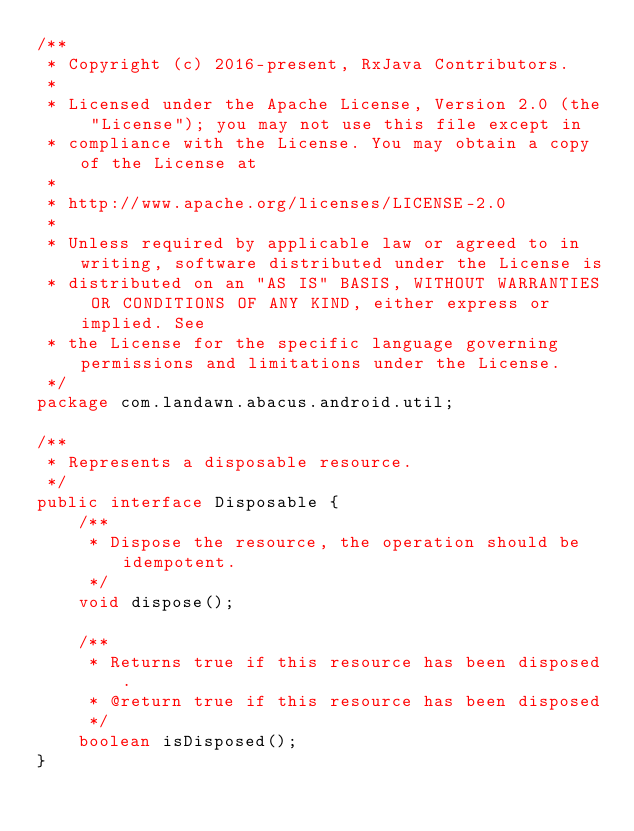<code> <loc_0><loc_0><loc_500><loc_500><_Java_>/**
 * Copyright (c) 2016-present, RxJava Contributors.
 *
 * Licensed under the Apache License, Version 2.0 (the "License"); you may not use this file except in
 * compliance with the License. You may obtain a copy of the License at
 *
 * http://www.apache.org/licenses/LICENSE-2.0
 *
 * Unless required by applicable law or agreed to in writing, software distributed under the License is
 * distributed on an "AS IS" BASIS, WITHOUT WARRANTIES OR CONDITIONS OF ANY KIND, either express or implied. See
 * the License for the specific language governing permissions and limitations under the License.
 */
package com.landawn.abacus.android.util;

/**
 * Represents a disposable resource.
 */
public interface Disposable {
    /**
     * Dispose the resource, the operation should be idempotent.
     */
    void dispose();

    /**
     * Returns true if this resource has been disposed.
     * @return true if this resource has been disposed
     */
    boolean isDisposed();
}
</code> 